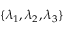<formula> <loc_0><loc_0><loc_500><loc_500>\{ \lambda _ { 1 } , \lambda _ { 2 } , \lambda _ { 3 } \}</formula> 